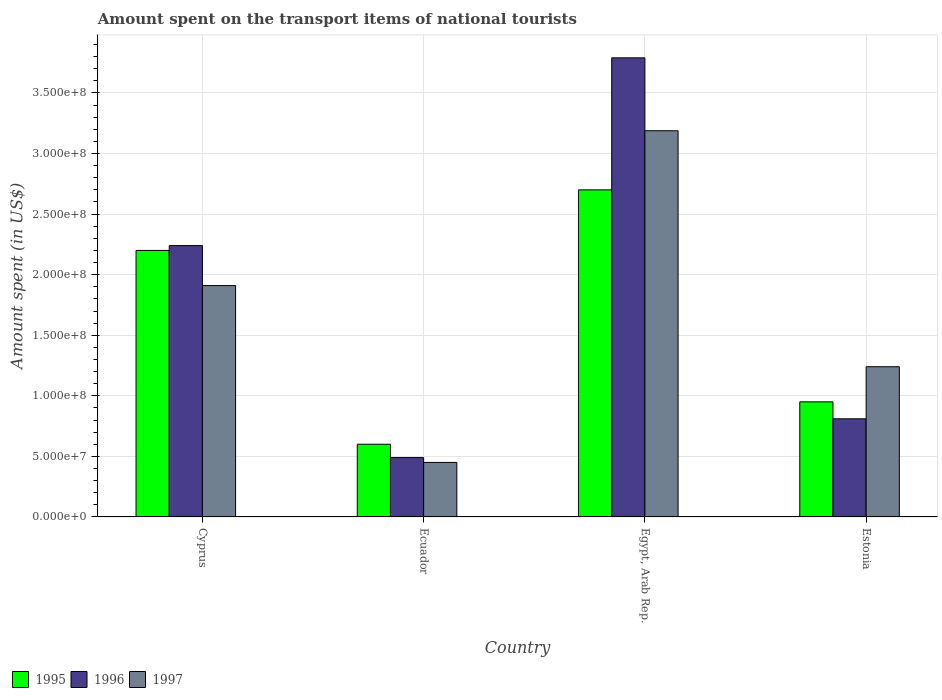How many different coloured bars are there?
Provide a short and direct response. 3. Are the number of bars per tick equal to the number of legend labels?
Ensure brevity in your answer.  Yes. Are the number of bars on each tick of the X-axis equal?
Give a very brief answer. Yes. How many bars are there on the 4th tick from the left?
Offer a very short reply. 3. How many bars are there on the 2nd tick from the right?
Your answer should be compact. 3. What is the label of the 2nd group of bars from the left?
Your response must be concise. Ecuador. In how many cases, is the number of bars for a given country not equal to the number of legend labels?
Your response must be concise. 0. What is the amount spent on the transport items of national tourists in 1997 in Estonia?
Your answer should be compact. 1.24e+08. Across all countries, what is the maximum amount spent on the transport items of national tourists in 1996?
Your answer should be very brief. 3.79e+08. Across all countries, what is the minimum amount spent on the transport items of national tourists in 1997?
Offer a very short reply. 4.50e+07. In which country was the amount spent on the transport items of national tourists in 1996 maximum?
Offer a terse response. Egypt, Arab Rep. In which country was the amount spent on the transport items of national tourists in 1995 minimum?
Offer a terse response. Ecuador. What is the total amount spent on the transport items of national tourists in 1997 in the graph?
Your answer should be very brief. 6.79e+08. What is the difference between the amount spent on the transport items of national tourists in 1995 in Ecuador and that in Estonia?
Provide a succinct answer. -3.50e+07. What is the difference between the amount spent on the transport items of national tourists in 1995 in Ecuador and the amount spent on the transport items of national tourists in 1996 in Estonia?
Offer a very short reply. -2.10e+07. What is the average amount spent on the transport items of national tourists in 1997 per country?
Offer a very short reply. 1.70e+08. What is the difference between the amount spent on the transport items of national tourists of/in 1997 and amount spent on the transport items of national tourists of/in 1996 in Estonia?
Offer a terse response. 4.30e+07. What is the ratio of the amount spent on the transport items of national tourists in 1996 in Cyprus to that in Ecuador?
Give a very brief answer. 4.57. What is the difference between the highest and the second highest amount spent on the transport items of national tourists in 1997?
Keep it short and to the point. 1.95e+08. What is the difference between the highest and the lowest amount spent on the transport items of national tourists in 1997?
Offer a terse response. 2.74e+08. Is the sum of the amount spent on the transport items of national tourists in 1995 in Cyprus and Estonia greater than the maximum amount spent on the transport items of national tourists in 1996 across all countries?
Offer a terse response. No. Are all the bars in the graph horizontal?
Your answer should be compact. No. Are the values on the major ticks of Y-axis written in scientific E-notation?
Ensure brevity in your answer.  Yes. Does the graph contain grids?
Give a very brief answer. Yes. Where does the legend appear in the graph?
Your answer should be compact. Bottom left. How many legend labels are there?
Your response must be concise. 3. How are the legend labels stacked?
Keep it short and to the point. Horizontal. What is the title of the graph?
Make the answer very short. Amount spent on the transport items of national tourists. What is the label or title of the X-axis?
Your answer should be very brief. Country. What is the label or title of the Y-axis?
Your response must be concise. Amount spent (in US$). What is the Amount spent (in US$) of 1995 in Cyprus?
Keep it short and to the point. 2.20e+08. What is the Amount spent (in US$) of 1996 in Cyprus?
Ensure brevity in your answer.  2.24e+08. What is the Amount spent (in US$) in 1997 in Cyprus?
Offer a very short reply. 1.91e+08. What is the Amount spent (in US$) in 1995 in Ecuador?
Your answer should be compact. 6.00e+07. What is the Amount spent (in US$) in 1996 in Ecuador?
Ensure brevity in your answer.  4.90e+07. What is the Amount spent (in US$) in 1997 in Ecuador?
Your answer should be compact. 4.50e+07. What is the Amount spent (in US$) in 1995 in Egypt, Arab Rep.?
Offer a terse response. 2.70e+08. What is the Amount spent (in US$) in 1996 in Egypt, Arab Rep.?
Give a very brief answer. 3.79e+08. What is the Amount spent (in US$) of 1997 in Egypt, Arab Rep.?
Ensure brevity in your answer.  3.19e+08. What is the Amount spent (in US$) of 1995 in Estonia?
Offer a terse response. 9.50e+07. What is the Amount spent (in US$) of 1996 in Estonia?
Offer a very short reply. 8.10e+07. What is the Amount spent (in US$) in 1997 in Estonia?
Keep it short and to the point. 1.24e+08. Across all countries, what is the maximum Amount spent (in US$) of 1995?
Give a very brief answer. 2.70e+08. Across all countries, what is the maximum Amount spent (in US$) in 1996?
Ensure brevity in your answer.  3.79e+08. Across all countries, what is the maximum Amount spent (in US$) of 1997?
Your response must be concise. 3.19e+08. Across all countries, what is the minimum Amount spent (in US$) of 1995?
Keep it short and to the point. 6.00e+07. Across all countries, what is the minimum Amount spent (in US$) of 1996?
Keep it short and to the point. 4.90e+07. Across all countries, what is the minimum Amount spent (in US$) in 1997?
Your answer should be very brief. 4.50e+07. What is the total Amount spent (in US$) of 1995 in the graph?
Your answer should be very brief. 6.45e+08. What is the total Amount spent (in US$) in 1996 in the graph?
Make the answer very short. 7.33e+08. What is the total Amount spent (in US$) in 1997 in the graph?
Make the answer very short. 6.79e+08. What is the difference between the Amount spent (in US$) in 1995 in Cyprus and that in Ecuador?
Offer a terse response. 1.60e+08. What is the difference between the Amount spent (in US$) in 1996 in Cyprus and that in Ecuador?
Ensure brevity in your answer.  1.75e+08. What is the difference between the Amount spent (in US$) of 1997 in Cyprus and that in Ecuador?
Provide a succinct answer. 1.46e+08. What is the difference between the Amount spent (in US$) of 1995 in Cyprus and that in Egypt, Arab Rep.?
Provide a short and direct response. -5.00e+07. What is the difference between the Amount spent (in US$) of 1996 in Cyprus and that in Egypt, Arab Rep.?
Offer a very short reply. -1.55e+08. What is the difference between the Amount spent (in US$) of 1997 in Cyprus and that in Egypt, Arab Rep.?
Offer a terse response. -1.28e+08. What is the difference between the Amount spent (in US$) in 1995 in Cyprus and that in Estonia?
Your response must be concise. 1.25e+08. What is the difference between the Amount spent (in US$) of 1996 in Cyprus and that in Estonia?
Give a very brief answer. 1.43e+08. What is the difference between the Amount spent (in US$) in 1997 in Cyprus and that in Estonia?
Make the answer very short. 6.70e+07. What is the difference between the Amount spent (in US$) of 1995 in Ecuador and that in Egypt, Arab Rep.?
Your answer should be compact. -2.10e+08. What is the difference between the Amount spent (in US$) in 1996 in Ecuador and that in Egypt, Arab Rep.?
Give a very brief answer. -3.30e+08. What is the difference between the Amount spent (in US$) of 1997 in Ecuador and that in Egypt, Arab Rep.?
Give a very brief answer. -2.74e+08. What is the difference between the Amount spent (in US$) in 1995 in Ecuador and that in Estonia?
Keep it short and to the point. -3.50e+07. What is the difference between the Amount spent (in US$) in 1996 in Ecuador and that in Estonia?
Provide a short and direct response. -3.20e+07. What is the difference between the Amount spent (in US$) of 1997 in Ecuador and that in Estonia?
Your answer should be very brief. -7.90e+07. What is the difference between the Amount spent (in US$) in 1995 in Egypt, Arab Rep. and that in Estonia?
Your response must be concise. 1.75e+08. What is the difference between the Amount spent (in US$) of 1996 in Egypt, Arab Rep. and that in Estonia?
Offer a terse response. 2.98e+08. What is the difference between the Amount spent (in US$) in 1997 in Egypt, Arab Rep. and that in Estonia?
Keep it short and to the point. 1.95e+08. What is the difference between the Amount spent (in US$) in 1995 in Cyprus and the Amount spent (in US$) in 1996 in Ecuador?
Keep it short and to the point. 1.71e+08. What is the difference between the Amount spent (in US$) of 1995 in Cyprus and the Amount spent (in US$) of 1997 in Ecuador?
Your answer should be very brief. 1.75e+08. What is the difference between the Amount spent (in US$) of 1996 in Cyprus and the Amount spent (in US$) of 1997 in Ecuador?
Offer a very short reply. 1.79e+08. What is the difference between the Amount spent (in US$) of 1995 in Cyprus and the Amount spent (in US$) of 1996 in Egypt, Arab Rep.?
Provide a short and direct response. -1.59e+08. What is the difference between the Amount spent (in US$) in 1995 in Cyprus and the Amount spent (in US$) in 1997 in Egypt, Arab Rep.?
Offer a terse response. -9.88e+07. What is the difference between the Amount spent (in US$) of 1996 in Cyprus and the Amount spent (in US$) of 1997 in Egypt, Arab Rep.?
Offer a very short reply. -9.48e+07. What is the difference between the Amount spent (in US$) in 1995 in Cyprus and the Amount spent (in US$) in 1996 in Estonia?
Your answer should be compact. 1.39e+08. What is the difference between the Amount spent (in US$) of 1995 in Cyprus and the Amount spent (in US$) of 1997 in Estonia?
Keep it short and to the point. 9.60e+07. What is the difference between the Amount spent (in US$) in 1996 in Cyprus and the Amount spent (in US$) in 1997 in Estonia?
Keep it short and to the point. 1.00e+08. What is the difference between the Amount spent (in US$) in 1995 in Ecuador and the Amount spent (in US$) in 1996 in Egypt, Arab Rep.?
Keep it short and to the point. -3.19e+08. What is the difference between the Amount spent (in US$) in 1995 in Ecuador and the Amount spent (in US$) in 1997 in Egypt, Arab Rep.?
Provide a short and direct response. -2.59e+08. What is the difference between the Amount spent (in US$) in 1996 in Ecuador and the Amount spent (in US$) in 1997 in Egypt, Arab Rep.?
Offer a terse response. -2.70e+08. What is the difference between the Amount spent (in US$) in 1995 in Ecuador and the Amount spent (in US$) in 1996 in Estonia?
Give a very brief answer. -2.10e+07. What is the difference between the Amount spent (in US$) in 1995 in Ecuador and the Amount spent (in US$) in 1997 in Estonia?
Ensure brevity in your answer.  -6.40e+07. What is the difference between the Amount spent (in US$) of 1996 in Ecuador and the Amount spent (in US$) of 1997 in Estonia?
Keep it short and to the point. -7.50e+07. What is the difference between the Amount spent (in US$) of 1995 in Egypt, Arab Rep. and the Amount spent (in US$) of 1996 in Estonia?
Offer a very short reply. 1.89e+08. What is the difference between the Amount spent (in US$) of 1995 in Egypt, Arab Rep. and the Amount spent (in US$) of 1997 in Estonia?
Make the answer very short. 1.46e+08. What is the difference between the Amount spent (in US$) of 1996 in Egypt, Arab Rep. and the Amount spent (in US$) of 1997 in Estonia?
Provide a succinct answer. 2.55e+08. What is the average Amount spent (in US$) of 1995 per country?
Your answer should be very brief. 1.61e+08. What is the average Amount spent (in US$) of 1996 per country?
Your response must be concise. 1.83e+08. What is the average Amount spent (in US$) in 1997 per country?
Your answer should be compact. 1.70e+08. What is the difference between the Amount spent (in US$) in 1995 and Amount spent (in US$) in 1996 in Cyprus?
Make the answer very short. -4.00e+06. What is the difference between the Amount spent (in US$) in 1995 and Amount spent (in US$) in 1997 in Cyprus?
Make the answer very short. 2.90e+07. What is the difference between the Amount spent (in US$) in 1996 and Amount spent (in US$) in 1997 in Cyprus?
Offer a very short reply. 3.30e+07. What is the difference between the Amount spent (in US$) of 1995 and Amount spent (in US$) of 1996 in Ecuador?
Keep it short and to the point. 1.10e+07. What is the difference between the Amount spent (in US$) of 1995 and Amount spent (in US$) of 1997 in Ecuador?
Give a very brief answer. 1.50e+07. What is the difference between the Amount spent (in US$) of 1996 and Amount spent (in US$) of 1997 in Ecuador?
Offer a very short reply. 4.00e+06. What is the difference between the Amount spent (in US$) of 1995 and Amount spent (in US$) of 1996 in Egypt, Arab Rep.?
Make the answer very short. -1.09e+08. What is the difference between the Amount spent (in US$) of 1995 and Amount spent (in US$) of 1997 in Egypt, Arab Rep.?
Offer a terse response. -4.88e+07. What is the difference between the Amount spent (in US$) of 1996 and Amount spent (in US$) of 1997 in Egypt, Arab Rep.?
Your answer should be compact. 6.02e+07. What is the difference between the Amount spent (in US$) in 1995 and Amount spent (in US$) in 1996 in Estonia?
Provide a succinct answer. 1.40e+07. What is the difference between the Amount spent (in US$) of 1995 and Amount spent (in US$) of 1997 in Estonia?
Provide a succinct answer. -2.90e+07. What is the difference between the Amount spent (in US$) of 1996 and Amount spent (in US$) of 1997 in Estonia?
Your answer should be very brief. -4.30e+07. What is the ratio of the Amount spent (in US$) of 1995 in Cyprus to that in Ecuador?
Ensure brevity in your answer.  3.67. What is the ratio of the Amount spent (in US$) in 1996 in Cyprus to that in Ecuador?
Your response must be concise. 4.57. What is the ratio of the Amount spent (in US$) in 1997 in Cyprus to that in Ecuador?
Give a very brief answer. 4.24. What is the ratio of the Amount spent (in US$) in 1995 in Cyprus to that in Egypt, Arab Rep.?
Your answer should be very brief. 0.81. What is the ratio of the Amount spent (in US$) of 1996 in Cyprus to that in Egypt, Arab Rep.?
Provide a succinct answer. 0.59. What is the ratio of the Amount spent (in US$) in 1997 in Cyprus to that in Egypt, Arab Rep.?
Make the answer very short. 0.6. What is the ratio of the Amount spent (in US$) in 1995 in Cyprus to that in Estonia?
Give a very brief answer. 2.32. What is the ratio of the Amount spent (in US$) of 1996 in Cyprus to that in Estonia?
Provide a short and direct response. 2.77. What is the ratio of the Amount spent (in US$) of 1997 in Cyprus to that in Estonia?
Give a very brief answer. 1.54. What is the ratio of the Amount spent (in US$) in 1995 in Ecuador to that in Egypt, Arab Rep.?
Your answer should be compact. 0.22. What is the ratio of the Amount spent (in US$) of 1996 in Ecuador to that in Egypt, Arab Rep.?
Give a very brief answer. 0.13. What is the ratio of the Amount spent (in US$) in 1997 in Ecuador to that in Egypt, Arab Rep.?
Keep it short and to the point. 0.14. What is the ratio of the Amount spent (in US$) of 1995 in Ecuador to that in Estonia?
Offer a very short reply. 0.63. What is the ratio of the Amount spent (in US$) of 1996 in Ecuador to that in Estonia?
Your response must be concise. 0.6. What is the ratio of the Amount spent (in US$) in 1997 in Ecuador to that in Estonia?
Keep it short and to the point. 0.36. What is the ratio of the Amount spent (in US$) in 1995 in Egypt, Arab Rep. to that in Estonia?
Your response must be concise. 2.84. What is the ratio of the Amount spent (in US$) of 1996 in Egypt, Arab Rep. to that in Estonia?
Your response must be concise. 4.68. What is the ratio of the Amount spent (in US$) in 1997 in Egypt, Arab Rep. to that in Estonia?
Offer a terse response. 2.57. What is the difference between the highest and the second highest Amount spent (in US$) in 1996?
Make the answer very short. 1.55e+08. What is the difference between the highest and the second highest Amount spent (in US$) in 1997?
Your answer should be compact. 1.28e+08. What is the difference between the highest and the lowest Amount spent (in US$) of 1995?
Your answer should be very brief. 2.10e+08. What is the difference between the highest and the lowest Amount spent (in US$) in 1996?
Provide a succinct answer. 3.30e+08. What is the difference between the highest and the lowest Amount spent (in US$) of 1997?
Your response must be concise. 2.74e+08. 